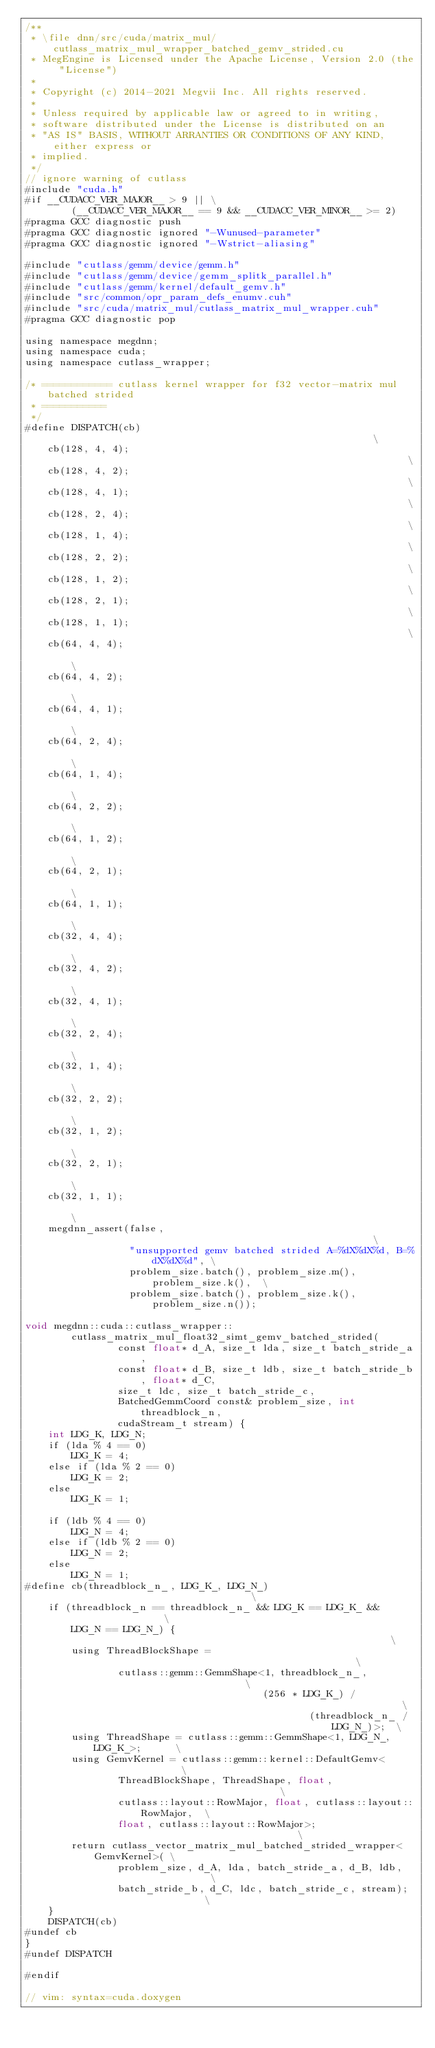Convert code to text. <code><loc_0><loc_0><loc_500><loc_500><_Cuda_>/**
 * \file dnn/src/cuda/matrix_mul/cutlass_matrix_mul_wrapper_batched_gemv_strided.cu
 * MegEngine is Licensed under the Apache License, Version 2.0 (the "License")
 *
 * Copyright (c) 2014-2021 Megvii Inc. All rights reserved.
 *
 * Unless required by applicable law or agreed to in writing,
 * software distributed under the License is distributed on an
 * "AS IS" BASIS, WITHOUT ARRANTIES OR CONDITIONS OF ANY KIND, either express or
 * implied.
 */
// ignore warning of cutlass
#include "cuda.h"
#if __CUDACC_VER_MAJOR__ > 9 || \
        (__CUDACC_VER_MAJOR__ == 9 && __CUDACC_VER_MINOR__ >= 2)
#pragma GCC diagnostic push
#pragma GCC diagnostic ignored "-Wunused-parameter"
#pragma GCC diagnostic ignored "-Wstrict-aliasing"

#include "cutlass/gemm/device/gemm.h"
#include "cutlass/gemm/device/gemm_splitk_parallel.h"
#include "cutlass/gemm/kernel/default_gemv.h"
#include "src/common/opr_param_defs_enumv.cuh"
#include "src/cuda/matrix_mul/cutlass_matrix_mul_wrapper.cuh"
#pragma GCC diagnostic pop

using namespace megdnn;
using namespace cuda;
using namespace cutlass_wrapper;

/* ============ cutlass kernel wrapper for f32 vector-matrix mul batched strided
 * ===========
 */
#define DISPATCH(cb)                                                         \
    cb(128, 4, 4);                                                           \
    cb(128, 4, 2);                                                           \
    cb(128, 4, 1);                                                           \
    cb(128, 2, 4);                                                           \
    cb(128, 1, 4);                                                           \
    cb(128, 2, 2);                                                           \
    cb(128, 1, 2);                                                           \
    cb(128, 2, 1);                                                           \
    cb(128, 1, 1);                                                           \
    cb(64, 4, 4);                                                            \
    cb(64, 4, 2);                                                            \
    cb(64, 4, 1);                                                            \
    cb(64, 2, 4);                                                            \
    cb(64, 1, 4);                                                            \
    cb(64, 2, 2);                                                            \
    cb(64, 1, 2);                                                            \
    cb(64, 2, 1);                                                            \
    cb(64, 1, 1);                                                            \
    cb(32, 4, 4);                                                            \
    cb(32, 4, 2);                                                            \
    cb(32, 4, 1);                                                            \
    cb(32, 2, 4);                                                            \
    cb(32, 1, 4);                                                            \
    cb(32, 2, 2);                                                            \
    cb(32, 1, 2);                                                            \
    cb(32, 2, 1);                                                            \
    cb(32, 1, 1);                                                            \
    megdnn_assert(false,                                                     \
                  "unsupported gemv batched strided A=%dX%dX%d, B=%dX%dX%d", \
                  problem_size.batch(), problem_size.m(), problem_size.k(),  \
                  problem_size.batch(), problem_size.k(), problem_size.n());

void megdnn::cuda::cutlass_wrapper::
        cutlass_matrix_mul_float32_simt_gemv_batched_strided(
                const float* d_A, size_t lda, size_t batch_stride_a,
                const float* d_B, size_t ldb, size_t batch_stride_b, float* d_C,
                size_t ldc, size_t batch_stride_c,
                BatchedGemmCoord const& problem_size, int threadblock_n,
                cudaStream_t stream) {
    int LDG_K, LDG_N;
    if (lda % 4 == 0)
        LDG_K = 4;
    else if (lda % 2 == 0)
        LDG_K = 2;
    else
        LDG_K = 1;

    if (ldb % 4 == 0)
        LDG_N = 4;
    else if (ldb % 2 == 0)
        LDG_N = 2;
    else
        LDG_N = 1;
#define cb(threadblock_n_, LDG_K_, LDG_N_)                                    \
    if (threadblock_n == threadblock_n_ && LDG_K == LDG_K_ &&                 \
        LDG_N == LDG_N_) {                                                    \
        using ThreadBlockShape =                                              \
                cutlass::gemm::GemmShape<1, threadblock_n_,                   \
                                         (256 * LDG_K_) /                     \
                                                 (threadblock_n_ / LDG_N_)>;  \
        using ThreadShape = cutlass::gemm::GemmShape<1, LDG_N_, LDG_K_>;      \
        using GemvKernel = cutlass::gemm::kernel::DefaultGemv<                \
                ThreadBlockShape, ThreadShape, float,                         \
                cutlass::layout::RowMajor, float, cutlass::layout::RowMajor,  \
                float, cutlass::layout::RowMajor>;                            \
        return cutlass_vector_matrix_mul_batched_strided_wrapper<GemvKernel>( \
                problem_size, d_A, lda, batch_stride_a, d_B, ldb,             \
                batch_stride_b, d_C, ldc, batch_stride_c, stream);            \
    }
    DISPATCH(cb)
#undef cb
}
#undef DISPATCH

#endif

// vim: syntax=cuda.doxygen
</code> 